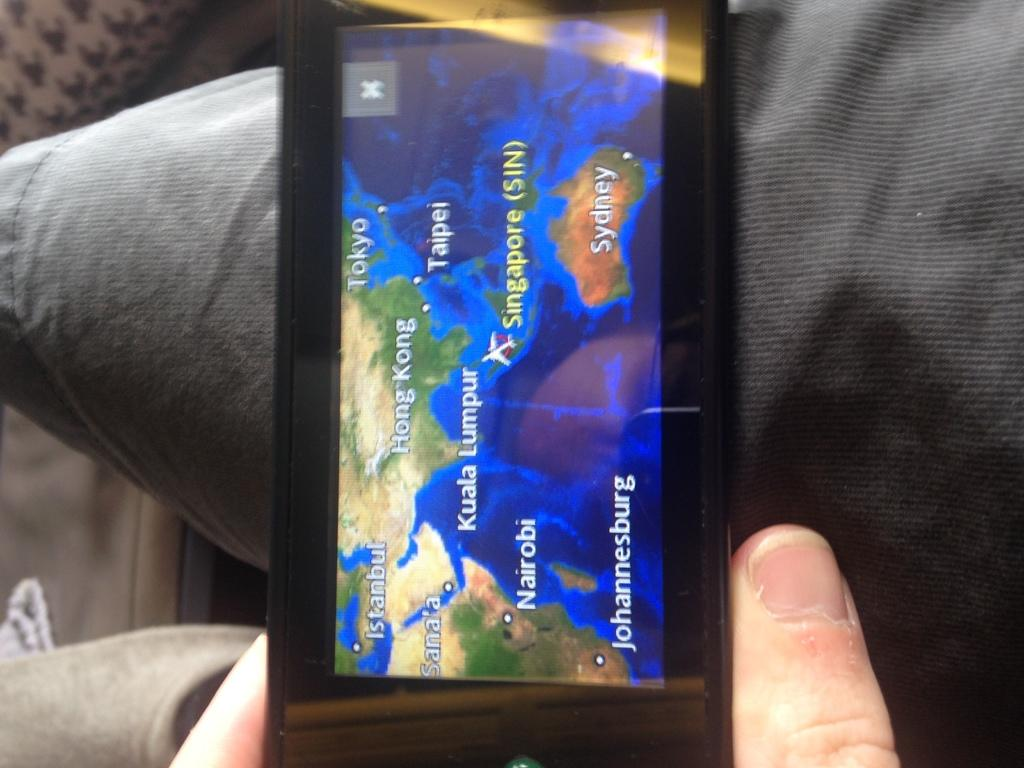<image>
Render a clear and concise summary of the photo. A  person holding a cellphone with a map displayed and Sydney is shown on on area of the map 